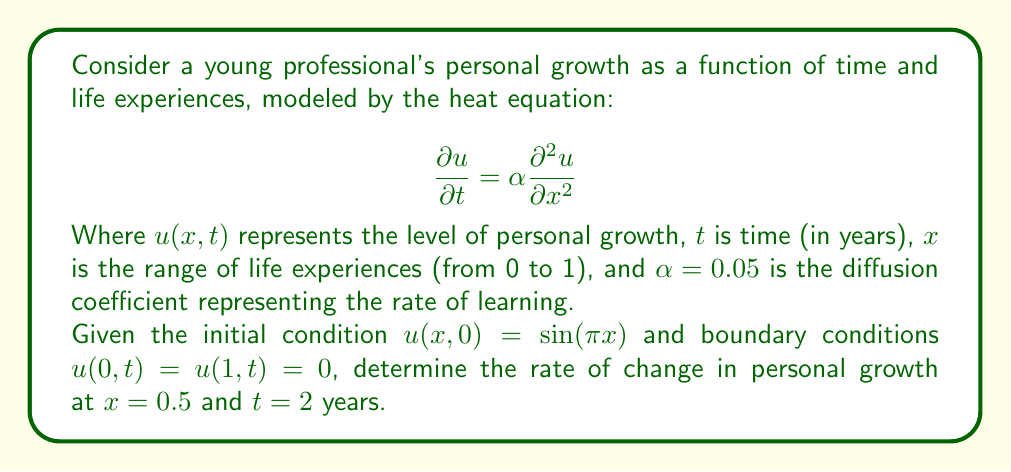Provide a solution to this math problem. To solve this problem, we follow these steps:

1) The general solution to the heat equation with the given boundary conditions is:

   $$u(x,t) = \sum_{n=1}^{\infty} B_n \sin(n\pi x) e^{-\alpha n^2\pi^2 t}$$

2) Given the initial condition $u(x,0) = \sin(\pi x)$, we can determine that $B_1 = 1$ and $B_n = 0$ for $n > 1$. Thus, our solution simplifies to:

   $$u(x,t) = \sin(\pi x) e^{-\alpha \pi^2 t}$$

3) To find the rate of change, we need to calculate $\frac{\partial u}{\partial t}$ at $x = 0.5$ and $t = 2$:

   $$\frac{\partial u}{\partial t} = -\alpha \pi^2 \sin(\pi x) e^{-\alpha \pi^2 t}$$

4) Substituting the given values:

   $$\frac{\partial u}{\partial t}(0.5, 2) = -0.05 \pi^2 \sin(\pi \cdot 0.5) e^{-0.05 \pi^2 \cdot 2}$$

5) Simplify:
   
   $$\frac{\partial u}{\partial t}(0.5, 2) = -0.05 \pi^2 \cdot 1 \cdot e^{-0.1 \pi^2}$$

6) Calculate the final value:

   $$\frac{\partial u}{\partial t}(0.5, 2) \approx -0.1139$$
Answer: The rate of change in personal growth at $x = 0.5$ and $t = 2$ years is approximately $-0.1139$ units per year. 